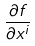Convert formula to latex. <formula><loc_0><loc_0><loc_500><loc_500>\frac { \partial f } { \partial x ^ { i } }</formula> 